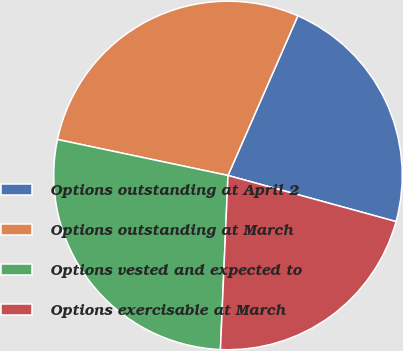Convert chart to OTSL. <chart><loc_0><loc_0><loc_500><loc_500><pie_chart><fcel>Options outstanding at April 2<fcel>Options outstanding at March<fcel>Options vested and expected to<fcel>Options exercisable at March<nl><fcel>22.7%<fcel>28.26%<fcel>27.62%<fcel>21.43%<nl></chart> 